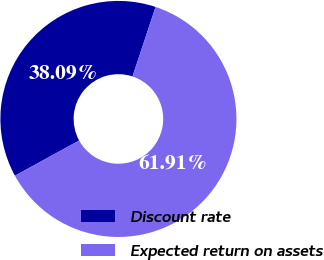<chart> <loc_0><loc_0><loc_500><loc_500><pie_chart><fcel>Discount rate<fcel>Expected return on assets<nl><fcel>38.09%<fcel>61.91%<nl></chart> 